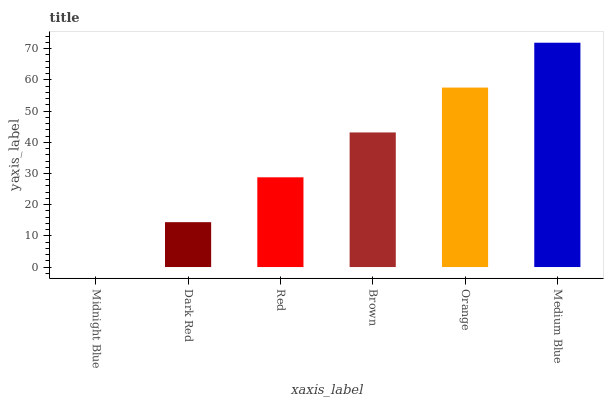Is Dark Red the minimum?
Answer yes or no. No. Is Dark Red the maximum?
Answer yes or no. No. Is Dark Red greater than Midnight Blue?
Answer yes or no. Yes. Is Midnight Blue less than Dark Red?
Answer yes or no. Yes. Is Midnight Blue greater than Dark Red?
Answer yes or no. No. Is Dark Red less than Midnight Blue?
Answer yes or no. No. Is Brown the high median?
Answer yes or no. Yes. Is Red the low median?
Answer yes or no. Yes. Is Medium Blue the high median?
Answer yes or no. No. Is Medium Blue the low median?
Answer yes or no. No. 